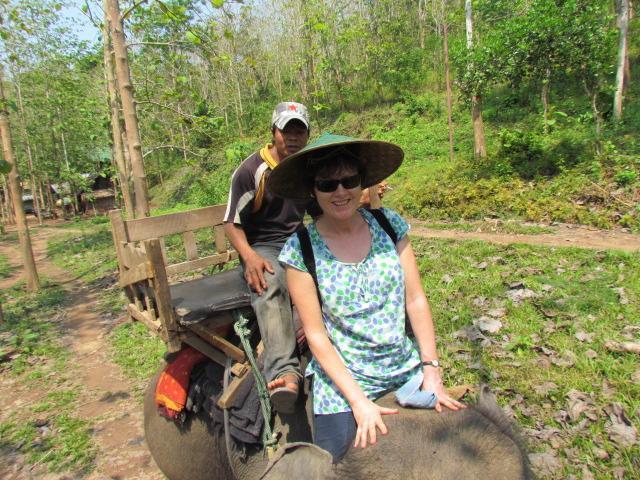How many men are there?
Give a very brief answer. 1. How many people are visible?
Give a very brief answer. 2. 